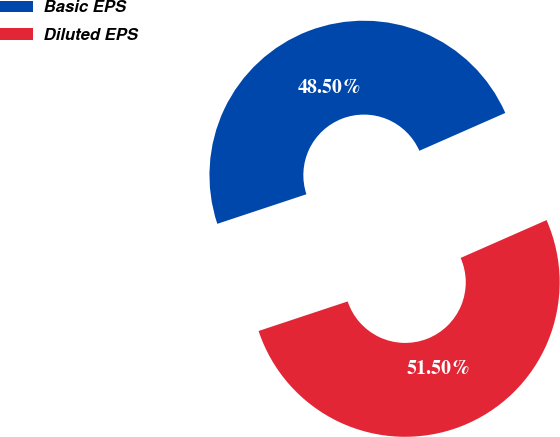Convert chart to OTSL. <chart><loc_0><loc_0><loc_500><loc_500><pie_chart><fcel>Basic EPS<fcel>Diluted EPS<nl><fcel>48.5%<fcel>51.5%<nl></chart> 